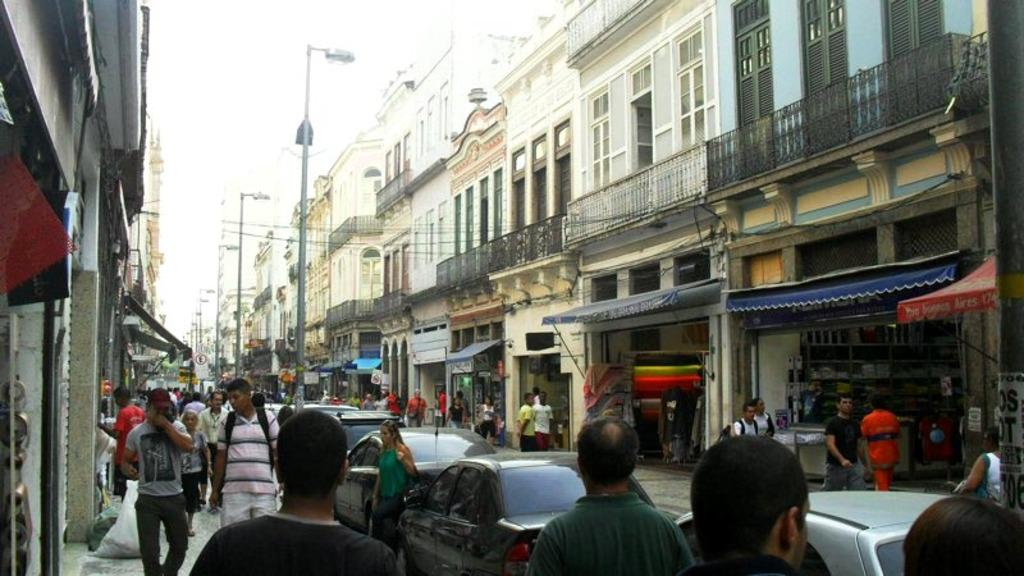What types of subjects can be seen in the image? There are people and vehicles in the image. What can be seen in the background of the image? Stalls, posters, poles, buildings, and the sky are visible in the background of the image. What is the overall setting of the image? The image appears to depict a roadside view. Can you see any steel structures in the image? There is no mention of steel structures in the provided facts, so it cannot be determined if any are present in the image. Are there any cobwebs visible in the image? There is no mention of cobwebs in the provided facts, so it cannot be determined if any are present in the image. 